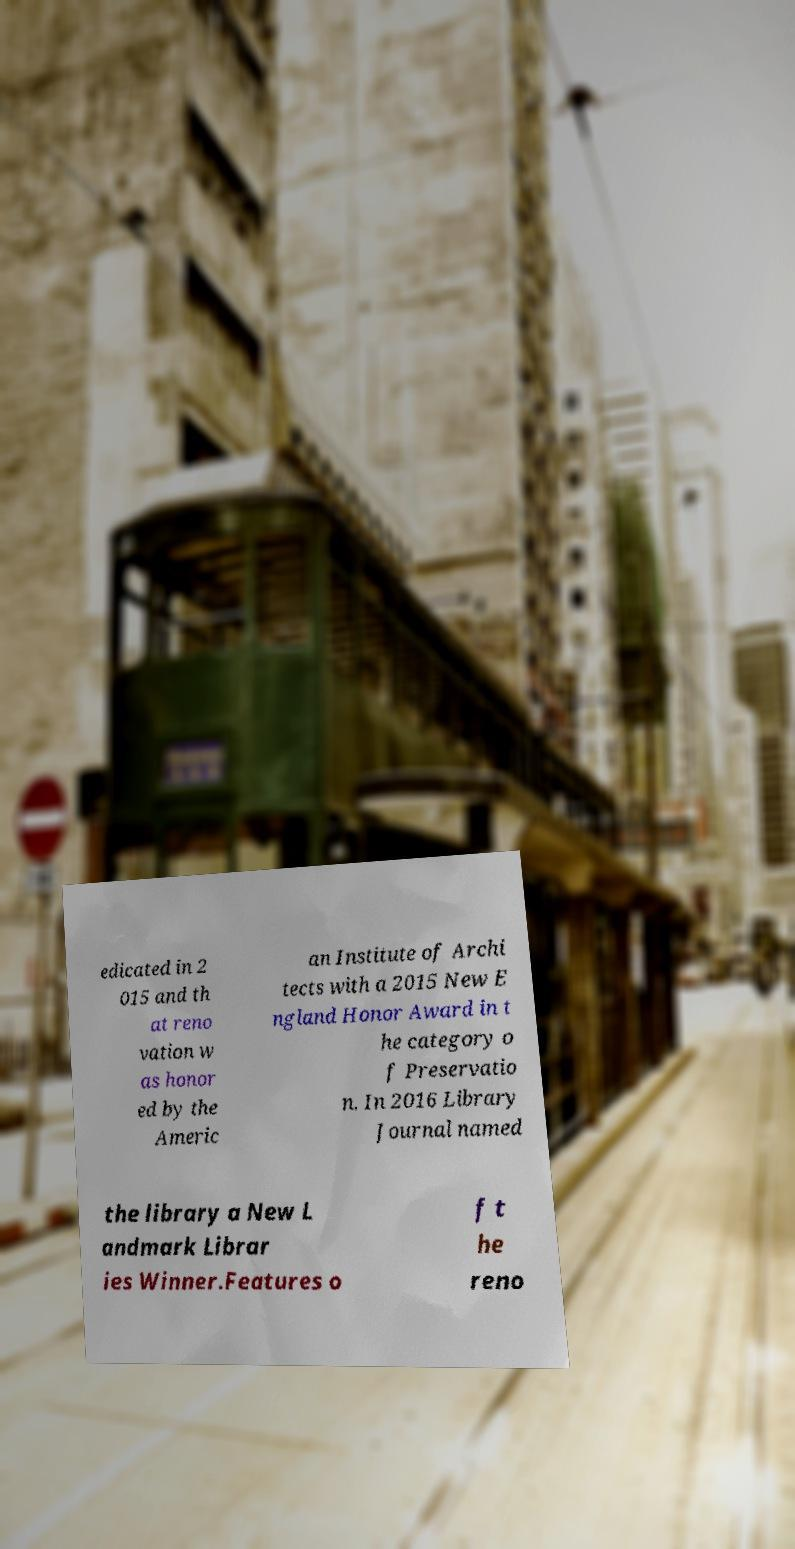Please identify and transcribe the text found in this image. edicated in 2 015 and th at reno vation w as honor ed by the Americ an Institute of Archi tects with a 2015 New E ngland Honor Award in t he category o f Preservatio n. In 2016 Library Journal named the library a New L andmark Librar ies Winner.Features o f t he reno 